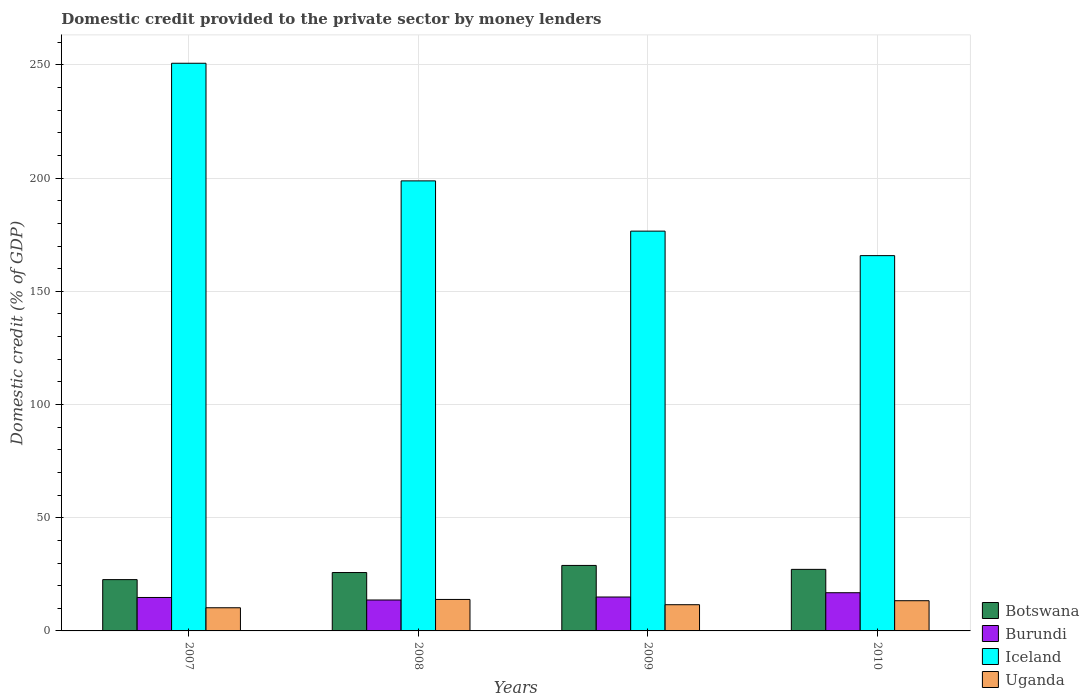Are the number of bars per tick equal to the number of legend labels?
Provide a succinct answer. Yes. How many bars are there on the 1st tick from the left?
Your answer should be very brief. 4. How many bars are there on the 3rd tick from the right?
Make the answer very short. 4. What is the label of the 1st group of bars from the left?
Ensure brevity in your answer.  2007. In how many cases, is the number of bars for a given year not equal to the number of legend labels?
Give a very brief answer. 0. What is the domestic credit provided to the private sector by money lenders in Uganda in 2008?
Make the answer very short. 13.9. Across all years, what is the maximum domestic credit provided to the private sector by money lenders in Iceland?
Ensure brevity in your answer.  250.76. Across all years, what is the minimum domestic credit provided to the private sector by money lenders in Botswana?
Give a very brief answer. 22.66. In which year was the domestic credit provided to the private sector by money lenders in Burundi minimum?
Your answer should be compact. 2008. What is the total domestic credit provided to the private sector by money lenders in Uganda in the graph?
Your answer should be compact. 49.06. What is the difference between the domestic credit provided to the private sector by money lenders in Botswana in 2009 and that in 2010?
Keep it short and to the point. 1.74. What is the difference between the domestic credit provided to the private sector by money lenders in Uganda in 2007 and the domestic credit provided to the private sector by money lenders in Iceland in 2009?
Provide a succinct answer. -166.37. What is the average domestic credit provided to the private sector by money lenders in Uganda per year?
Provide a short and direct response. 12.26. In the year 2008, what is the difference between the domestic credit provided to the private sector by money lenders in Uganda and domestic credit provided to the private sector by money lenders in Burundi?
Your answer should be compact. 0.24. What is the ratio of the domestic credit provided to the private sector by money lenders in Uganda in 2007 to that in 2009?
Offer a very short reply. 0.88. Is the domestic credit provided to the private sector by money lenders in Iceland in 2007 less than that in 2009?
Your response must be concise. No. Is the difference between the domestic credit provided to the private sector by money lenders in Uganda in 2007 and 2009 greater than the difference between the domestic credit provided to the private sector by money lenders in Burundi in 2007 and 2009?
Give a very brief answer. No. What is the difference between the highest and the second highest domestic credit provided to the private sector by money lenders in Iceland?
Give a very brief answer. 51.96. What is the difference between the highest and the lowest domestic credit provided to the private sector by money lenders in Uganda?
Offer a terse response. 3.67. What does the 4th bar from the left in 2008 represents?
Make the answer very short. Uganda. What does the 3rd bar from the right in 2009 represents?
Ensure brevity in your answer.  Burundi. Is it the case that in every year, the sum of the domestic credit provided to the private sector by money lenders in Uganda and domestic credit provided to the private sector by money lenders in Burundi is greater than the domestic credit provided to the private sector by money lenders in Iceland?
Make the answer very short. No. How many bars are there?
Ensure brevity in your answer.  16. How many years are there in the graph?
Your response must be concise. 4. What is the difference between two consecutive major ticks on the Y-axis?
Ensure brevity in your answer.  50. Where does the legend appear in the graph?
Make the answer very short. Bottom right. What is the title of the graph?
Provide a succinct answer. Domestic credit provided to the private sector by money lenders. What is the label or title of the Y-axis?
Make the answer very short. Domestic credit (% of GDP). What is the Domestic credit (% of GDP) in Botswana in 2007?
Offer a terse response. 22.66. What is the Domestic credit (% of GDP) in Burundi in 2007?
Ensure brevity in your answer.  14.78. What is the Domestic credit (% of GDP) in Iceland in 2007?
Your response must be concise. 250.76. What is the Domestic credit (% of GDP) of Uganda in 2007?
Give a very brief answer. 10.23. What is the Domestic credit (% of GDP) of Botswana in 2008?
Your response must be concise. 25.79. What is the Domestic credit (% of GDP) in Burundi in 2008?
Offer a very short reply. 13.66. What is the Domestic credit (% of GDP) in Iceland in 2008?
Offer a terse response. 198.81. What is the Domestic credit (% of GDP) in Uganda in 2008?
Keep it short and to the point. 13.9. What is the Domestic credit (% of GDP) in Botswana in 2009?
Make the answer very short. 28.93. What is the Domestic credit (% of GDP) of Burundi in 2009?
Make the answer very short. 14.98. What is the Domestic credit (% of GDP) in Iceland in 2009?
Provide a short and direct response. 176.6. What is the Domestic credit (% of GDP) of Uganda in 2009?
Your answer should be compact. 11.58. What is the Domestic credit (% of GDP) of Botswana in 2010?
Make the answer very short. 27.19. What is the Domestic credit (% of GDP) of Burundi in 2010?
Offer a terse response. 16.87. What is the Domestic credit (% of GDP) in Iceland in 2010?
Your answer should be very brief. 165.78. What is the Domestic credit (% of GDP) of Uganda in 2010?
Keep it short and to the point. 13.34. Across all years, what is the maximum Domestic credit (% of GDP) of Botswana?
Give a very brief answer. 28.93. Across all years, what is the maximum Domestic credit (% of GDP) in Burundi?
Your response must be concise. 16.87. Across all years, what is the maximum Domestic credit (% of GDP) in Iceland?
Provide a succinct answer. 250.76. Across all years, what is the maximum Domestic credit (% of GDP) in Uganda?
Provide a succinct answer. 13.9. Across all years, what is the minimum Domestic credit (% of GDP) in Botswana?
Provide a succinct answer. 22.66. Across all years, what is the minimum Domestic credit (% of GDP) in Burundi?
Provide a succinct answer. 13.66. Across all years, what is the minimum Domestic credit (% of GDP) of Iceland?
Ensure brevity in your answer.  165.78. Across all years, what is the minimum Domestic credit (% of GDP) of Uganda?
Keep it short and to the point. 10.23. What is the total Domestic credit (% of GDP) of Botswana in the graph?
Ensure brevity in your answer.  104.58. What is the total Domestic credit (% of GDP) of Burundi in the graph?
Offer a very short reply. 60.29. What is the total Domestic credit (% of GDP) in Iceland in the graph?
Your answer should be compact. 791.96. What is the total Domestic credit (% of GDP) in Uganda in the graph?
Offer a terse response. 49.06. What is the difference between the Domestic credit (% of GDP) in Botswana in 2007 and that in 2008?
Provide a short and direct response. -3.12. What is the difference between the Domestic credit (% of GDP) of Burundi in 2007 and that in 2008?
Your answer should be compact. 1.11. What is the difference between the Domestic credit (% of GDP) of Iceland in 2007 and that in 2008?
Your answer should be very brief. 51.96. What is the difference between the Domestic credit (% of GDP) in Uganda in 2007 and that in 2008?
Your answer should be very brief. -3.67. What is the difference between the Domestic credit (% of GDP) of Botswana in 2007 and that in 2009?
Your answer should be very brief. -6.27. What is the difference between the Domestic credit (% of GDP) of Burundi in 2007 and that in 2009?
Your response must be concise. -0.2. What is the difference between the Domestic credit (% of GDP) of Iceland in 2007 and that in 2009?
Your answer should be compact. 74.16. What is the difference between the Domestic credit (% of GDP) in Uganda in 2007 and that in 2009?
Offer a very short reply. -1.35. What is the difference between the Domestic credit (% of GDP) in Botswana in 2007 and that in 2010?
Give a very brief answer. -4.53. What is the difference between the Domestic credit (% of GDP) in Burundi in 2007 and that in 2010?
Ensure brevity in your answer.  -2.1. What is the difference between the Domestic credit (% of GDP) in Iceland in 2007 and that in 2010?
Keep it short and to the point. 84.98. What is the difference between the Domestic credit (% of GDP) of Uganda in 2007 and that in 2010?
Your response must be concise. -3.11. What is the difference between the Domestic credit (% of GDP) of Botswana in 2008 and that in 2009?
Provide a short and direct response. -3.14. What is the difference between the Domestic credit (% of GDP) of Burundi in 2008 and that in 2009?
Ensure brevity in your answer.  -1.32. What is the difference between the Domestic credit (% of GDP) of Iceland in 2008 and that in 2009?
Offer a very short reply. 22.2. What is the difference between the Domestic credit (% of GDP) in Uganda in 2008 and that in 2009?
Provide a succinct answer. 2.32. What is the difference between the Domestic credit (% of GDP) in Botswana in 2008 and that in 2010?
Provide a succinct answer. -1.41. What is the difference between the Domestic credit (% of GDP) of Burundi in 2008 and that in 2010?
Your answer should be compact. -3.21. What is the difference between the Domestic credit (% of GDP) in Iceland in 2008 and that in 2010?
Offer a terse response. 33.02. What is the difference between the Domestic credit (% of GDP) of Uganda in 2008 and that in 2010?
Your answer should be very brief. 0.56. What is the difference between the Domestic credit (% of GDP) in Botswana in 2009 and that in 2010?
Offer a terse response. 1.74. What is the difference between the Domestic credit (% of GDP) in Burundi in 2009 and that in 2010?
Your answer should be very brief. -1.89. What is the difference between the Domestic credit (% of GDP) of Iceland in 2009 and that in 2010?
Ensure brevity in your answer.  10.82. What is the difference between the Domestic credit (% of GDP) of Uganda in 2009 and that in 2010?
Make the answer very short. -1.77. What is the difference between the Domestic credit (% of GDP) in Botswana in 2007 and the Domestic credit (% of GDP) in Burundi in 2008?
Give a very brief answer. 9. What is the difference between the Domestic credit (% of GDP) in Botswana in 2007 and the Domestic credit (% of GDP) in Iceland in 2008?
Offer a terse response. -176.14. What is the difference between the Domestic credit (% of GDP) in Botswana in 2007 and the Domestic credit (% of GDP) in Uganda in 2008?
Provide a succinct answer. 8.76. What is the difference between the Domestic credit (% of GDP) of Burundi in 2007 and the Domestic credit (% of GDP) of Iceland in 2008?
Offer a very short reply. -184.03. What is the difference between the Domestic credit (% of GDP) of Burundi in 2007 and the Domestic credit (% of GDP) of Uganda in 2008?
Your answer should be compact. 0.87. What is the difference between the Domestic credit (% of GDP) in Iceland in 2007 and the Domestic credit (% of GDP) in Uganda in 2008?
Offer a very short reply. 236.86. What is the difference between the Domestic credit (% of GDP) in Botswana in 2007 and the Domestic credit (% of GDP) in Burundi in 2009?
Give a very brief answer. 7.68. What is the difference between the Domestic credit (% of GDP) in Botswana in 2007 and the Domestic credit (% of GDP) in Iceland in 2009?
Your answer should be very brief. -153.94. What is the difference between the Domestic credit (% of GDP) of Botswana in 2007 and the Domestic credit (% of GDP) of Uganda in 2009?
Your answer should be very brief. 11.09. What is the difference between the Domestic credit (% of GDP) of Burundi in 2007 and the Domestic credit (% of GDP) of Iceland in 2009?
Give a very brief answer. -161.83. What is the difference between the Domestic credit (% of GDP) in Burundi in 2007 and the Domestic credit (% of GDP) in Uganda in 2009?
Provide a short and direct response. 3.2. What is the difference between the Domestic credit (% of GDP) of Iceland in 2007 and the Domestic credit (% of GDP) of Uganda in 2009?
Offer a very short reply. 239.18. What is the difference between the Domestic credit (% of GDP) of Botswana in 2007 and the Domestic credit (% of GDP) of Burundi in 2010?
Offer a terse response. 5.79. What is the difference between the Domestic credit (% of GDP) in Botswana in 2007 and the Domestic credit (% of GDP) in Iceland in 2010?
Ensure brevity in your answer.  -143.12. What is the difference between the Domestic credit (% of GDP) of Botswana in 2007 and the Domestic credit (% of GDP) of Uganda in 2010?
Keep it short and to the point. 9.32. What is the difference between the Domestic credit (% of GDP) of Burundi in 2007 and the Domestic credit (% of GDP) of Iceland in 2010?
Offer a terse response. -151.01. What is the difference between the Domestic credit (% of GDP) of Burundi in 2007 and the Domestic credit (% of GDP) of Uganda in 2010?
Keep it short and to the point. 1.43. What is the difference between the Domestic credit (% of GDP) of Iceland in 2007 and the Domestic credit (% of GDP) of Uganda in 2010?
Provide a short and direct response. 237.42. What is the difference between the Domestic credit (% of GDP) in Botswana in 2008 and the Domestic credit (% of GDP) in Burundi in 2009?
Your answer should be very brief. 10.81. What is the difference between the Domestic credit (% of GDP) in Botswana in 2008 and the Domestic credit (% of GDP) in Iceland in 2009?
Keep it short and to the point. -150.81. What is the difference between the Domestic credit (% of GDP) of Botswana in 2008 and the Domestic credit (% of GDP) of Uganda in 2009?
Give a very brief answer. 14.21. What is the difference between the Domestic credit (% of GDP) in Burundi in 2008 and the Domestic credit (% of GDP) in Iceland in 2009?
Ensure brevity in your answer.  -162.94. What is the difference between the Domestic credit (% of GDP) in Burundi in 2008 and the Domestic credit (% of GDP) in Uganda in 2009?
Your response must be concise. 2.09. What is the difference between the Domestic credit (% of GDP) in Iceland in 2008 and the Domestic credit (% of GDP) in Uganda in 2009?
Provide a succinct answer. 187.23. What is the difference between the Domestic credit (% of GDP) of Botswana in 2008 and the Domestic credit (% of GDP) of Burundi in 2010?
Make the answer very short. 8.92. What is the difference between the Domestic credit (% of GDP) in Botswana in 2008 and the Domestic credit (% of GDP) in Iceland in 2010?
Your answer should be compact. -140. What is the difference between the Domestic credit (% of GDP) in Botswana in 2008 and the Domestic credit (% of GDP) in Uganda in 2010?
Offer a very short reply. 12.44. What is the difference between the Domestic credit (% of GDP) of Burundi in 2008 and the Domestic credit (% of GDP) of Iceland in 2010?
Provide a succinct answer. -152.12. What is the difference between the Domestic credit (% of GDP) in Burundi in 2008 and the Domestic credit (% of GDP) in Uganda in 2010?
Your response must be concise. 0.32. What is the difference between the Domestic credit (% of GDP) of Iceland in 2008 and the Domestic credit (% of GDP) of Uganda in 2010?
Ensure brevity in your answer.  185.46. What is the difference between the Domestic credit (% of GDP) of Botswana in 2009 and the Domestic credit (% of GDP) of Burundi in 2010?
Keep it short and to the point. 12.06. What is the difference between the Domestic credit (% of GDP) in Botswana in 2009 and the Domestic credit (% of GDP) in Iceland in 2010?
Make the answer very short. -136.85. What is the difference between the Domestic credit (% of GDP) in Botswana in 2009 and the Domestic credit (% of GDP) in Uganda in 2010?
Provide a succinct answer. 15.59. What is the difference between the Domestic credit (% of GDP) of Burundi in 2009 and the Domestic credit (% of GDP) of Iceland in 2010?
Offer a terse response. -150.8. What is the difference between the Domestic credit (% of GDP) of Burundi in 2009 and the Domestic credit (% of GDP) of Uganda in 2010?
Provide a succinct answer. 1.64. What is the difference between the Domestic credit (% of GDP) of Iceland in 2009 and the Domestic credit (% of GDP) of Uganda in 2010?
Offer a terse response. 163.26. What is the average Domestic credit (% of GDP) of Botswana per year?
Provide a succinct answer. 26.14. What is the average Domestic credit (% of GDP) in Burundi per year?
Make the answer very short. 15.07. What is the average Domestic credit (% of GDP) in Iceland per year?
Ensure brevity in your answer.  197.99. What is the average Domestic credit (% of GDP) of Uganda per year?
Make the answer very short. 12.26. In the year 2007, what is the difference between the Domestic credit (% of GDP) in Botswana and Domestic credit (% of GDP) in Burundi?
Make the answer very short. 7.89. In the year 2007, what is the difference between the Domestic credit (% of GDP) of Botswana and Domestic credit (% of GDP) of Iceland?
Make the answer very short. -228.1. In the year 2007, what is the difference between the Domestic credit (% of GDP) of Botswana and Domestic credit (% of GDP) of Uganda?
Your answer should be compact. 12.43. In the year 2007, what is the difference between the Domestic credit (% of GDP) of Burundi and Domestic credit (% of GDP) of Iceland?
Provide a succinct answer. -235.99. In the year 2007, what is the difference between the Domestic credit (% of GDP) of Burundi and Domestic credit (% of GDP) of Uganda?
Offer a terse response. 4.54. In the year 2007, what is the difference between the Domestic credit (% of GDP) in Iceland and Domestic credit (% of GDP) in Uganda?
Make the answer very short. 240.53. In the year 2008, what is the difference between the Domestic credit (% of GDP) in Botswana and Domestic credit (% of GDP) in Burundi?
Your response must be concise. 12.12. In the year 2008, what is the difference between the Domestic credit (% of GDP) in Botswana and Domestic credit (% of GDP) in Iceland?
Provide a short and direct response. -173.02. In the year 2008, what is the difference between the Domestic credit (% of GDP) of Botswana and Domestic credit (% of GDP) of Uganda?
Offer a terse response. 11.89. In the year 2008, what is the difference between the Domestic credit (% of GDP) in Burundi and Domestic credit (% of GDP) in Iceland?
Provide a succinct answer. -185.14. In the year 2008, what is the difference between the Domestic credit (% of GDP) of Burundi and Domestic credit (% of GDP) of Uganda?
Provide a short and direct response. -0.24. In the year 2008, what is the difference between the Domestic credit (% of GDP) of Iceland and Domestic credit (% of GDP) of Uganda?
Your response must be concise. 184.91. In the year 2009, what is the difference between the Domestic credit (% of GDP) in Botswana and Domestic credit (% of GDP) in Burundi?
Ensure brevity in your answer.  13.95. In the year 2009, what is the difference between the Domestic credit (% of GDP) in Botswana and Domestic credit (% of GDP) in Iceland?
Your answer should be very brief. -147.67. In the year 2009, what is the difference between the Domestic credit (% of GDP) in Botswana and Domestic credit (% of GDP) in Uganda?
Your answer should be very brief. 17.35. In the year 2009, what is the difference between the Domestic credit (% of GDP) of Burundi and Domestic credit (% of GDP) of Iceland?
Ensure brevity in your answer.  -161.62. In the year 2009, what is the difference between the Domestic credit (% of GDP) of Burundi and Domestic credit (% of GDP) of Uganda?
Make the answer very short. 3.4. In the year 2009, what is the difference between the Domestic credit (% of GDP) of Iceland and Domestic credit (% of GDP) of Uganda?
Give a very brief answer. 165.02. In the year 2010, what is the difference between the Domestic credit (% of GDP) in Botswana and Domestic credit (% of GDP) in Burundi?
Your answer should be very brief. 10.32. In the year 2010, what is the difference between the Domestic credit (% of GDP) in Botswana and Domestic credit (% of GDP) in Iceland?
Your answer should be compact. -138.59. In the year 2010, what is the difference between the Domestic credit (% of GDP) of Botswana and Domestic credit (% of GDP) of Uganda?
Offer a terse response. 13.85. In the year 2010, what is the difference between the Domestic credit (% of GDP) of Burundi and Domestic credit (% of GDP) of Iceland?
Your answer should be very brief. -148.91. In the year 2010, what is the difference between the Domestic credit (% of GDP) of Burundi and Domestic credit (% of GDP) of Uganda?
Keep it short and to the point. 3.53. In the year 2010, what is the difference between the Domestic credit (% of GDP) in Iceland and Domestic credit (% of GDP) in Uganda?
Offer a terse response. 152.44. What is the ratio of the Domestic credit (% of GDP) of Botswana in 2007 to that in 2008?
Your answer should be very brief. 0.88. What is the ratio of the Domestic credit (% of GDP) in Burundi in 2007 to that in 2008?
Keep it short and to the point. 1.08. What is the ratio of the Domestic credit (% of GDP) in Iceland in 2007 to that in 2008?
Provide a short and direct response. 1.26. What is the ratio of the Domestic credit (% of GDP) in Uganda in 2007 to that in 2008?
Offer a very short reply. 0.74. What is the ratio of the Domestic credit (% of GDP) in Botswana in 2007 to that in 2009?
Offer a very short reply. 0.78. What is the ratio of the Domestic credit (% of GDP) of Burundi in 2007 to that in 2009?
Keep it short and to the point. 0.99. What is the ratio of the Domestic credit (% of GDP) of Iceland in 2007 to that in 2009?
Provide a short and direct response. 1.42. What is the ratio of the Domestic credit (% of GDP) in Uganda in 2007 to that in 2009?
Ensure brevity in your answer.  0.88. What is the ratio of the Domestic credit (% of GDP) in Botswana in 2007 to that in 2010?
Keep it short and to the point. 0.83. What is the ratio of the Domestic credit (% of GDP) in Burundi in 2007 to that in 2010?
Offer a terse response. 0.88. What is the ratio of the Domestic credit (% of GDP) in Iceland in 2007 to that in 2010?
Provide a succinct answer. 1.51. What is the ratio of the Domestic credit (% of GDP) of Uganda in 2007 to that in 2010?
Your response must be concise. 0.77. What is the ratio of the Domestic credit (% of GDP) in Botswana in 2008 to that in 2009?
Your response must be concise. 0.89. What is the ratio of the Domestic credit (% of GDP) in Burundi in 2008 to that in 2009?
Your answer should be very brief. 0.91. What is the ratio of the Domestic credit (% of GDP) in Iceland in 2008 to that in 2009?
Offer a very short reply. 1.13. What is the ratio of the Domestic credit (% of GDP) of Uganda in 2008 to that in 2009?
Offer a very short reply. 1.2. What is the ratio of the Domestic credit (% of GDP) in Botswana in 2008 to that in 2010?
Offer a very short reply. 0.95. What is the ratio of the Domestic credit (% of GDP) in Burundi in 2008 to that in 2010?
Provide a succinct answer. 0.81. What is the ratio of the Domestic credit (% of GDP) of Iceland in 2008 to that in 2010?
Your answer should be compact. 1.2. What is the ratio of the Domestic credit (% of GDP) of Uganda in 2008 to that in 2010?
Your response must be concise. 1.04. What is the ratio of the Domestic credit (% of GDP) of Botswana in 2009 to that in 2010?
Your answer should be compact. 1.06. What is the ratio of the Domestic credit (% of GDP) in Burundi in 2009 to that in 2010?
Offer a terse response. 0.89. What is the ratio of the Domestic credit (% of GDP) of Iceland in 2009 to that in 2010?
Offer a very short reply. 1.07. What is the ratio of the Domestic credit (% of GDP) in Uganda in 2009 to that in 2010?
Give a very brief answer. 0.87. What is the difference between the highest and the second highest Domestic credit (% of GDP) of Botswana?
Keep it short and to the point. 1.74. What is the difference between the highest and the second highest Domestic credit (% of GDP) of Burundi?
Ensure brevity in your answer.  1.89. What is the difference between the highest and the second highest Domestic credit (% of GDP) in Iceland?
Your answer should be compact. 51.96. What is the difference between the highest and the second highest Domestic credit (% of GDP) of Uganda?
Ensure brevity in your answer.  0.56. What is the difference between the highest and the lowest Domestic credit (% of GDP) in Botswana?
Your response must be concise. 6.27. What is the difference between the highest and the lowest Domestic credit (% of GDP) of Burundi?
Keep it short and to the point. 3.21. What is the difference between the highest and the lowest Domestic credit (% of GDP) in Iceland?
Offer a terse response. 84.98. What is the difference between the highest and the lowest Domestic credit (% of GDP) in Uganda?
Make the answer very short. 3.67. 